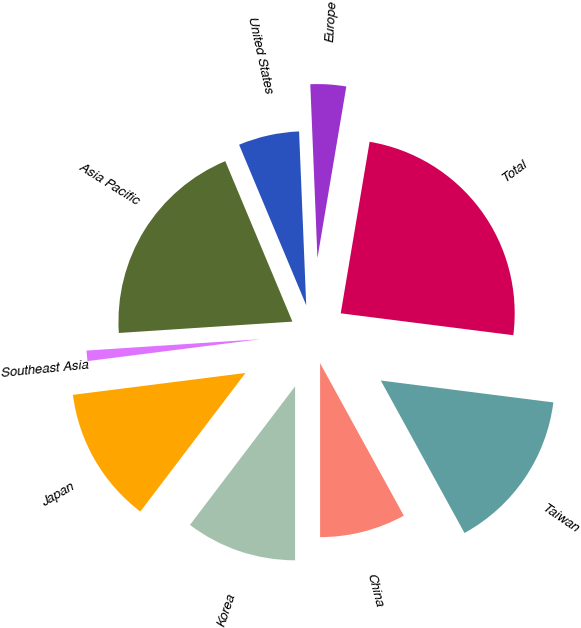Convert chart to OTSL. <chart><loc_0><loc_0><loc_500><loc_500><pie_chart><fcel>Taiwan<fcel>China<fcel>Korea<fcel>Japan<fcel>Southeast Asia<fcel>Asia Pacific<fcel>United States<fcel>Europe<fcel>Total<nl><fcel>15.0%<fcel>7.99%<fcel>10.33%<fcel>12.66%<fcel>0.97%<fcel>19.73%<fcel>5.65%<fcel>3.31%<fcel>24.35%<nl></chart> 